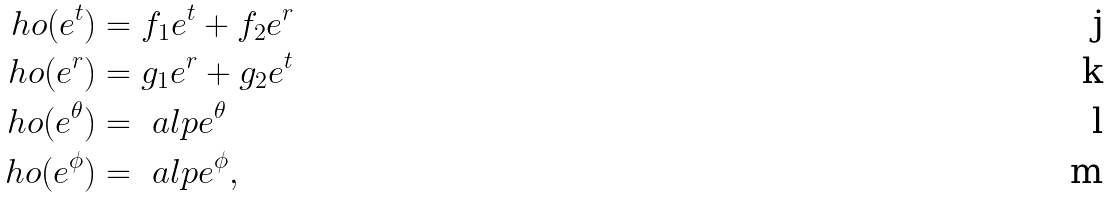Convert formula to latex. <formula><loc_0><loc_0><loc_500><loc_500>\ h o ( e ^ { t } ) & = f _ { 1 } e ^ { t } + f _ { 2 } e ^ { r } \\ \ h o ( e ^ { r } ) & = g _ { 1 } e ^ { r } + g _ { 2 } e ^ { t } \\ \ h o ( e ^ { \theta } ) & = \ a l p e ^ { \theta } \\ \ h o ( e ^ { \phi } ) & = \ a l p e ^ { \phi } ,</formula> 